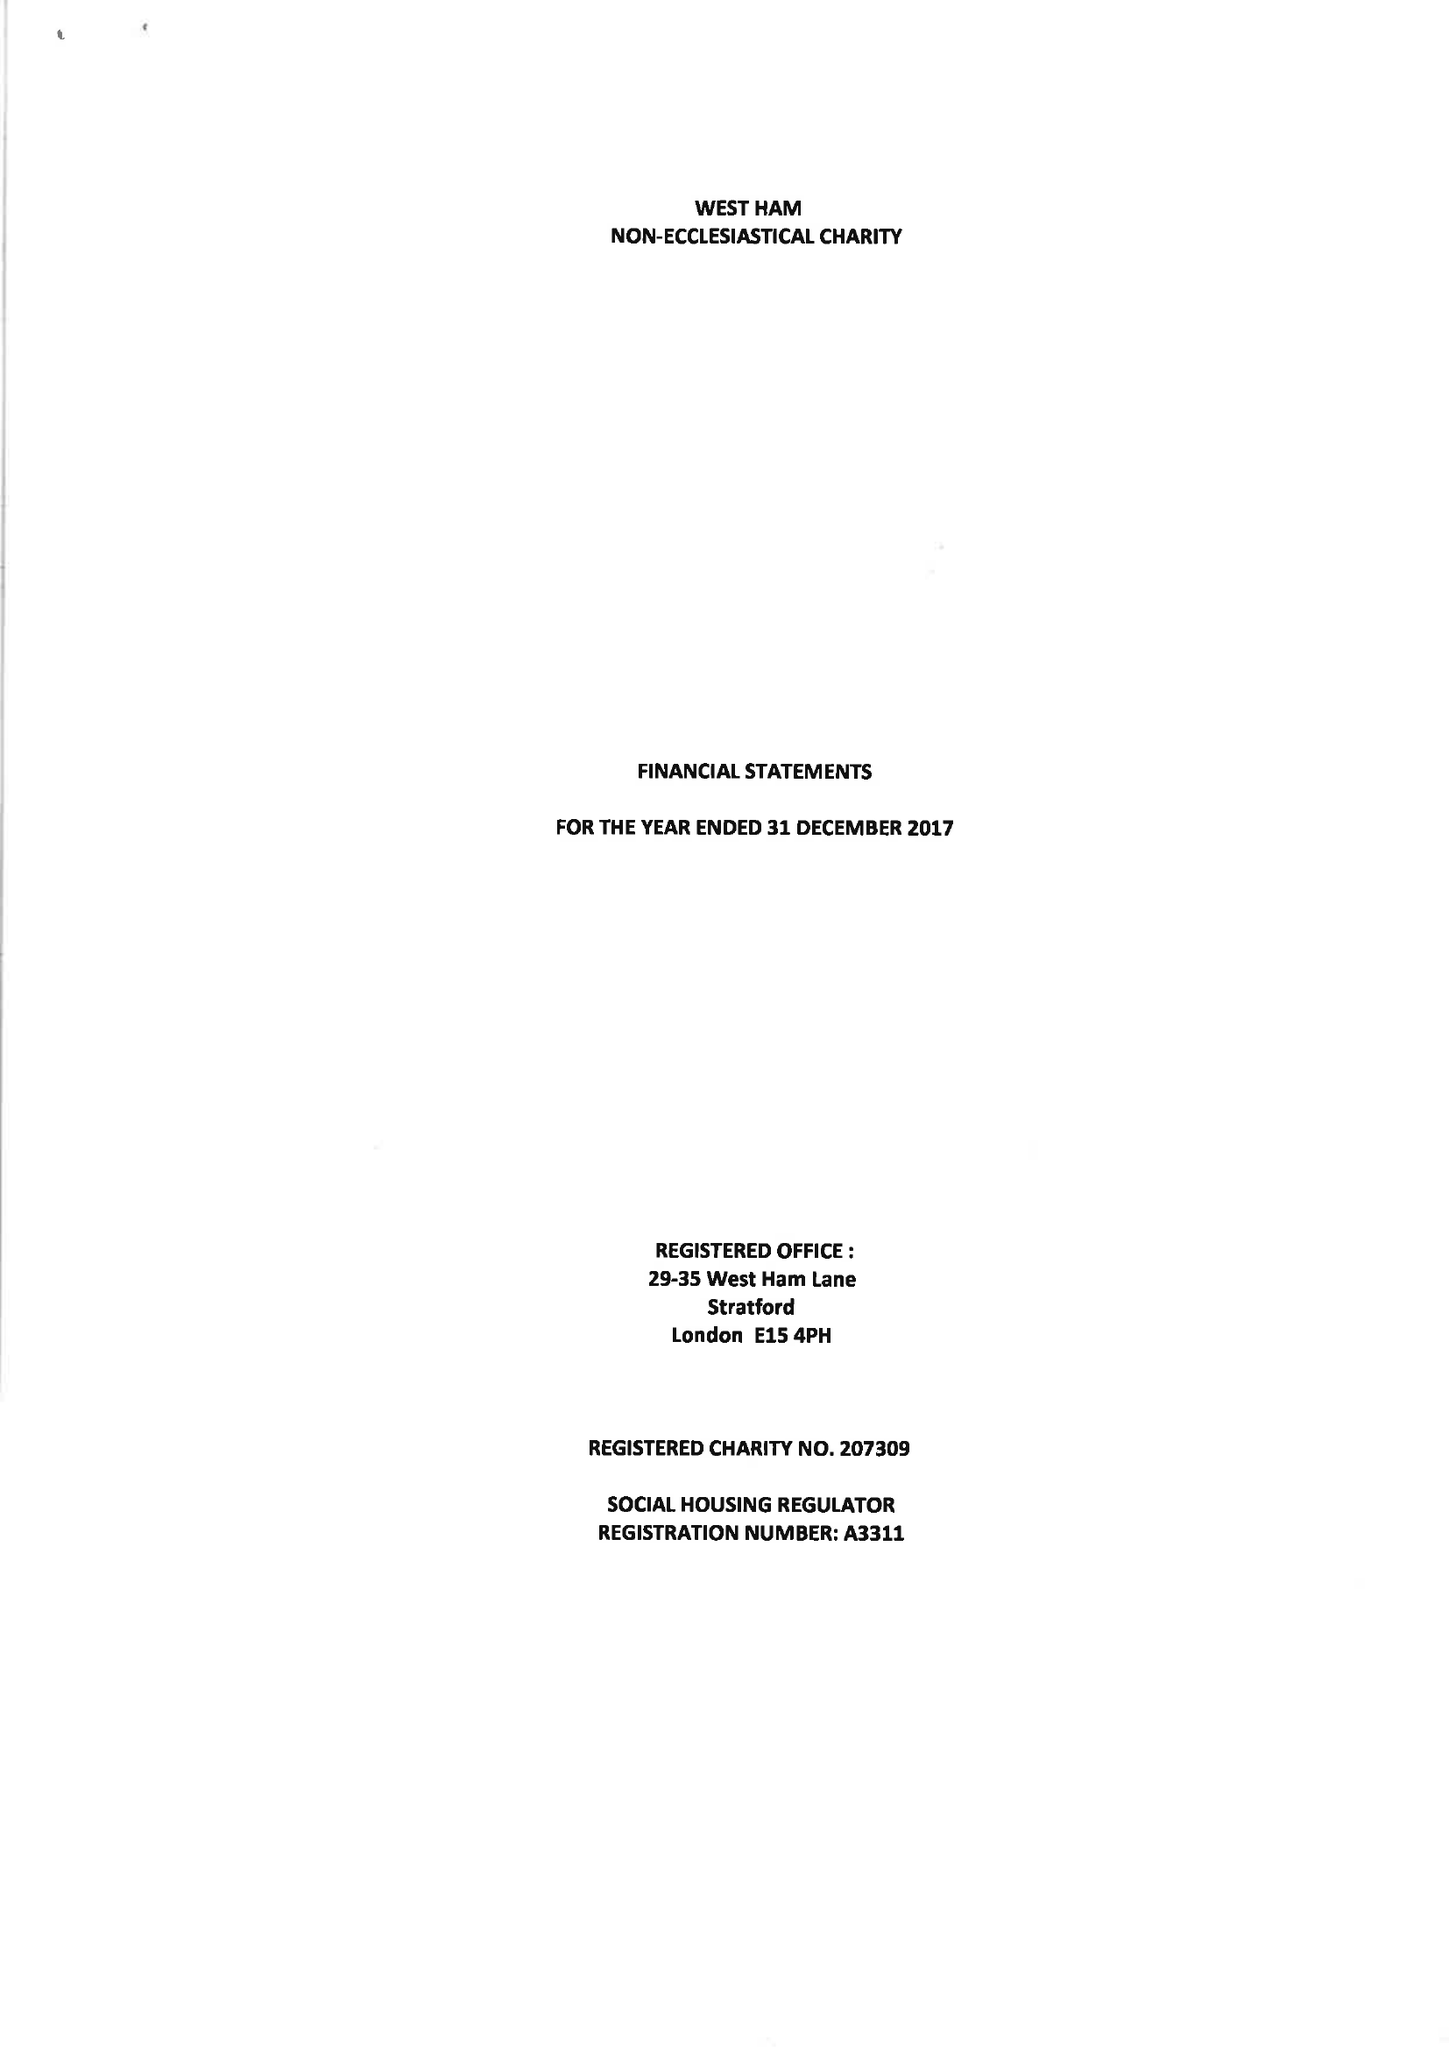What is the value for the address__post_town?
Answer the question using a single word or phrase. LONDON 